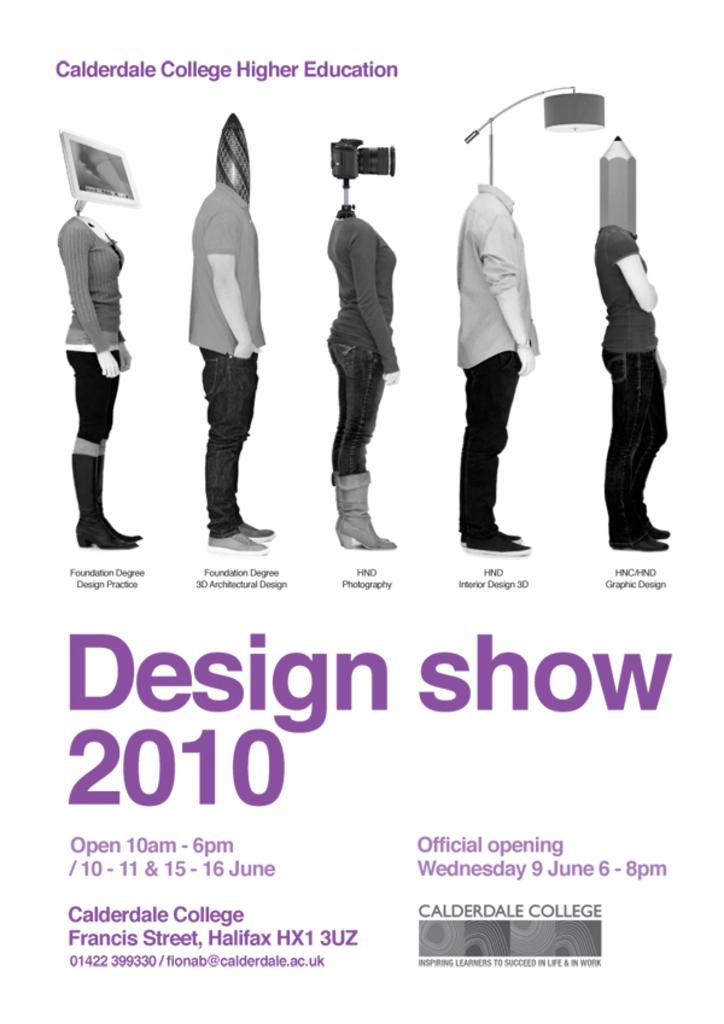What is located in the middle of the image? There are pictures of persons in the middle of the image. What can be found at the bottom of the image? There is text written at the bottom of the image. What is present at the top of the image? There is text written at the top of the image. How many pieces of coal are visible in the image? There is no coal present in the image. Can you tell me which player's turn it is in the chess game shown in the image? There is no chess game present in the image. 